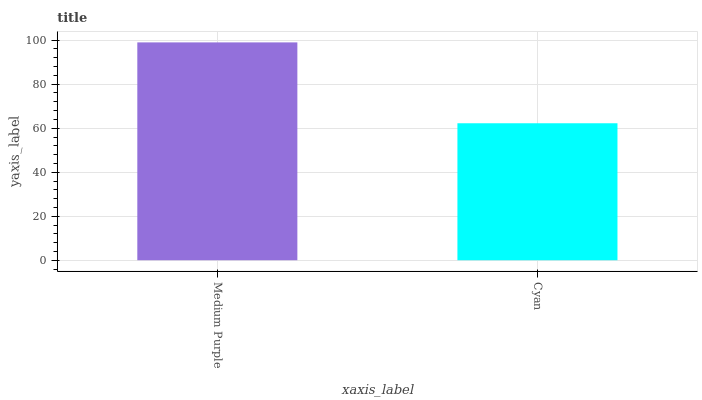Is Cyan the minimum?
Answer yes or no. Yes. Is Medium Purple the maximum?
Answer yes or no. Yes. Is Cyan the maximum?
Answer yes or no. No. Is Medium Purple greater than Cyan?
Answer yes or no. Yes. Is Cyan less than Medium Purple?
Answer yes or no. Yes. Is Cyan greater than Medium Purple?
Answer yes or no. No. Is Medium Purple less than Cyan?
Answer yes or no. No. Is Medium Purple the high median?
Answer yes or no. Yes. Is Cyan the low median?
Answer yes or no. Yes. Is Cyan the high median?
Answer yes or no. No. Is Medium Purple the low median?
Answer yes or no. No. 